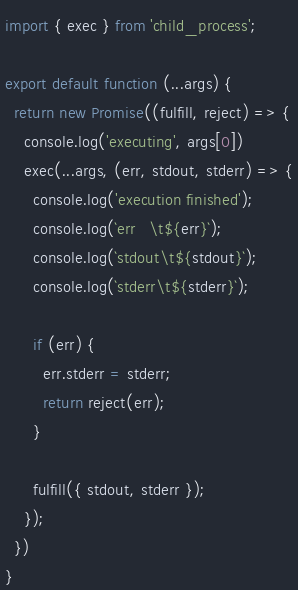<code> <loc_0><loc_0><loc_500><loc_500><_JavaScript_>import { exec } from 'child_process';

export default function (...args) {
  return new Promise((fulfill, reject) => {
    console.log('executing', args[0])
    exec(...args, (err, stdout, stderr) => {
      console.log('execution finished');
      console.log(`err   \t${err}`);
      console.log(`stdout\t${stdout}`);
      console.log(`stderr\t${stderr}`);

      if (err) {
        err.stderr = stderr;
        return reject(err);
      }

      fulfill({ stdout, stderr });
    });
  })
}
</code> 